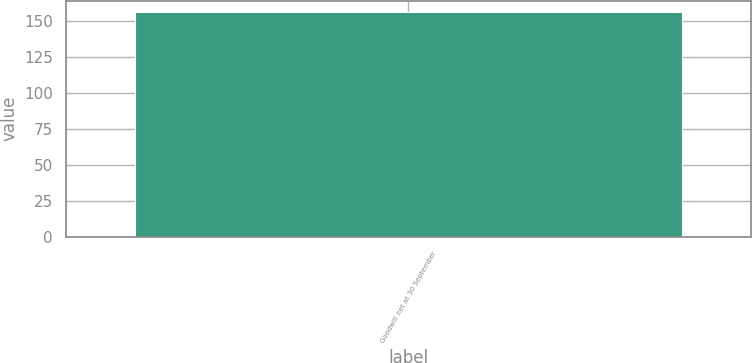Convert chart. <chart><loc_0><loc_0><loc_500><loc_500><bar_chart><fcel>Goodwill net at 30 September<nl><fcel>156.3<nl></chart> 